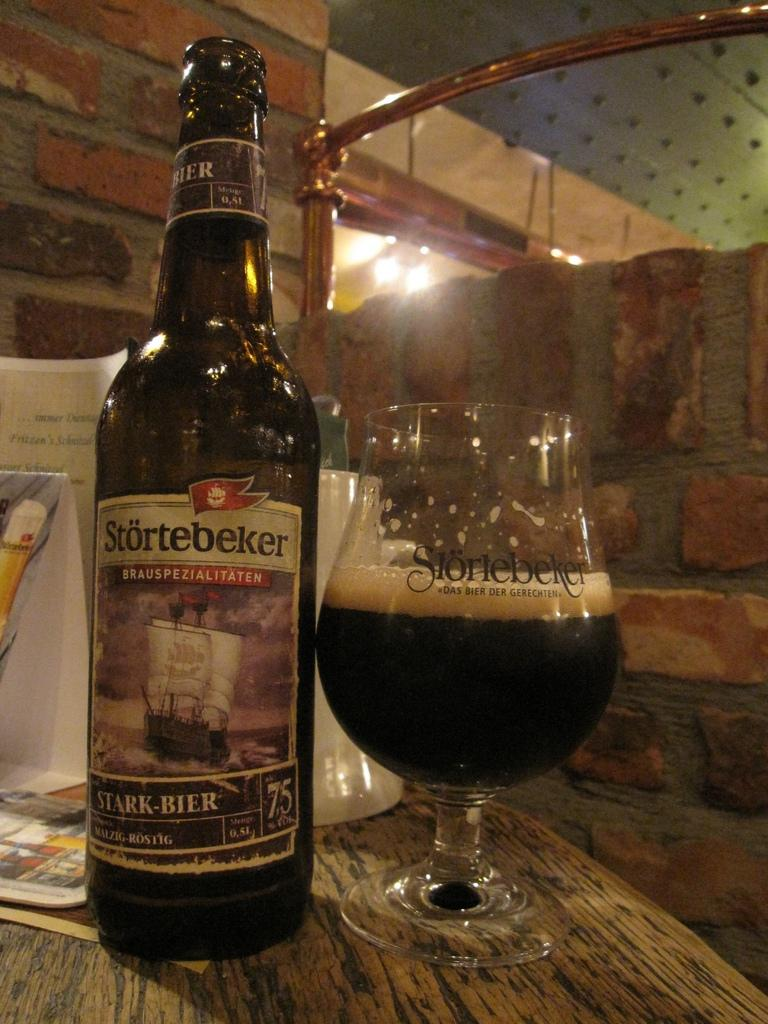<image>
Render a clear and concise summary of the photo. A bottle of stortebeker beer sits on a wooden table in front of menus and next to a glass bearing the same name and half full of beer. 